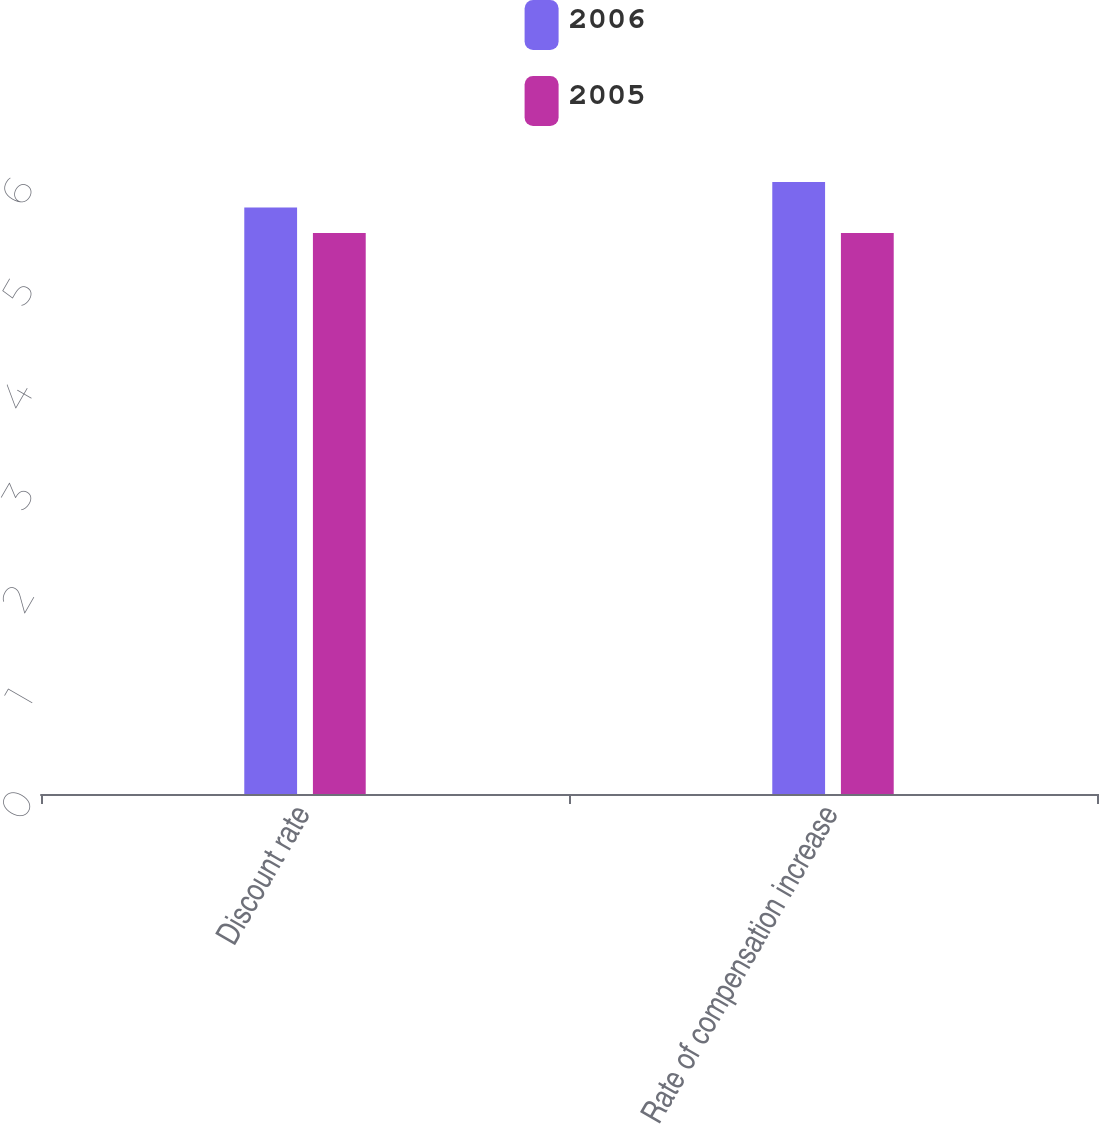Convert chart. <chart><loc_0><loc_0><loc_500><loc_500><stacked_bar_chart><ecel><fcel>Discount rate<fcel>Rate of compensation increase<nl><fcel>2006<fcel>5.75<fcel>6<nl><fcel>2005<fcel>5.5<fcel>5.5<nl></chart> 